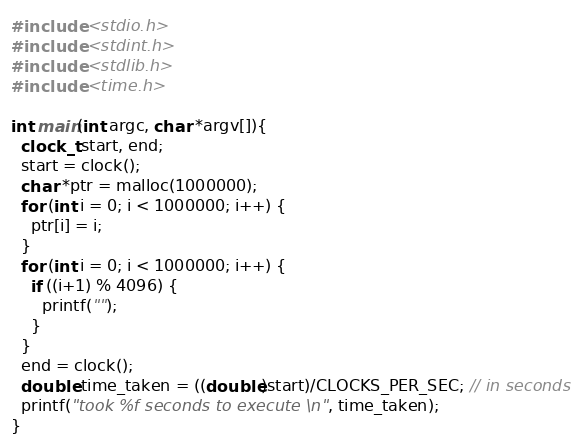<code> <loc_0><loc_0><loc_500><loc_500><_C_>#include <stdio.h>
#include <stdint.h>
#include <stdlib.h>
#include <time.h>

int main(int argc, char *argv[]){
  clock_t start, end;
  start = clock();
  char *ptr = malloc(1000000);
  for (int i = 0; i < 1000000; i++) {
    ptr[i] = i;
  }
  for (int i = 0; i < 1000000; i++) {
    if ((i+1) % 4096) {
      printf("");
    }
  }
  end = clock();
  double time_taken = ((double)start)/CLOCKS_PER_SEC; // in seconds 
  printf("took %f seconds to execute \n", time_taken); 
}
</code> 